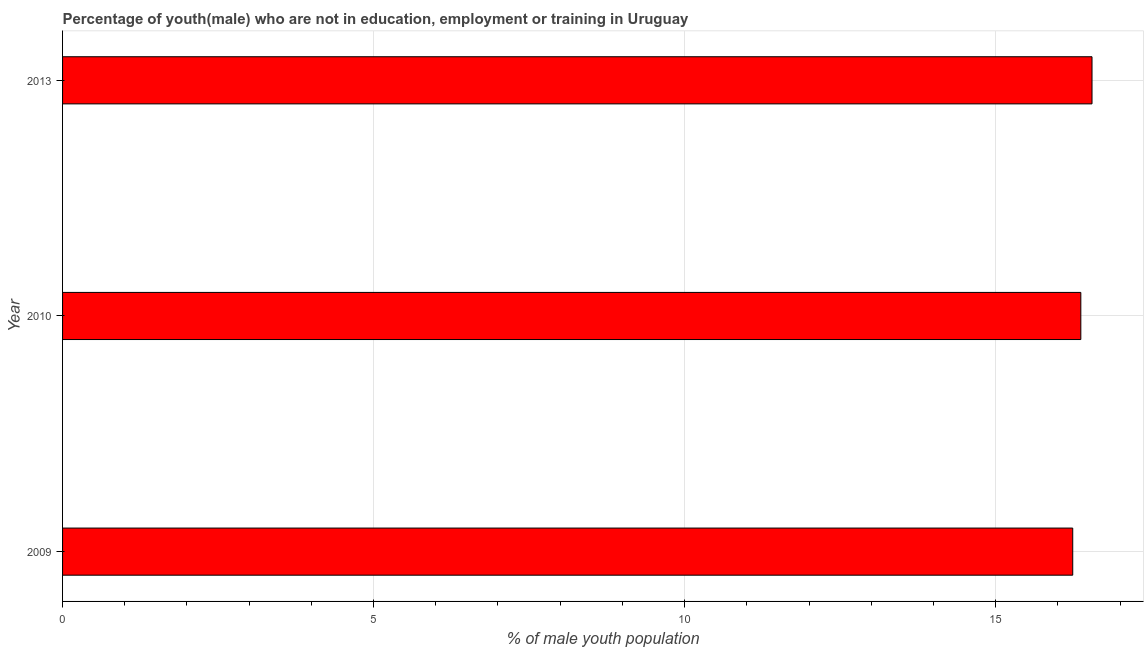Does the graph contain any zero values?
Keep it short and to the point. No. Does the graph contain grids?
Offer a terse response. Yes. What is the title of the graph?
Provide a short and direct response. Percentage of youth(male) who are not in education, employment or training in Uruguay. What is the label or title of the X-axis?
Keep it short and to the point. % of male youth population. What is the unemployed male youth population in 2013?
Keep it short and to the point. 16.55. Across all years, what is the maximum unemployed male youth population?
Your answer should be very brief. 16.55. Across all years, what is the minimum unemployed male youth population?
Offer a terse response. 16.24. In which year was the unemployed male youth population maximum?
Provide a succinct answer. 2013. In which year was the unemployed male youth population minimum?
Provide a succinct answer. 2009. What is the sum of the unemployed male youth population?
Give a very brief answer. 49.16. What is the difference between the unemployed male youth population in 2009 and 2013?
Your answer should be very brief. -0.31. What is the average unemployed male youth population per year?
Ensure brevity in your answer.  16.39. What is the median unemployed male youth population?
Your answer should be compact. 16.37. In how many years, is the unemployed male youth population greater than 10 %?
Offer a very short reply. 3. Do a majority of the years between 2009 and 2013 (inclusive) have unemployed male youth population greater than 16 %?
Keep it short and to the point. Yes. Is the difference between the unemployed male youth population in 2010 and 2013 greater than the difference between any two years?
Offer a very short reply. No. What is the difference between the highest and the second highest unemployed male youth population?
Your answer should be compact. 0.18. What is the difference between the highest and the lowest unemployed male youth population?
Your response must be concise. 0.31. In how many years, is the unemployed male youth population greater than the average unemployed male youth population taken over all years?
Make the answer very short. 1. Are the values on the major ticks of X-axis written in scientific E-notation?
Offer a very short reply. No. What is the % of male youth population in 2009?
Offer a terse response. 16.24. What is the % of male youth population in 2010?
Offer a very short reply. 16.37. What is the % of male youth population of 2013?
Your answer should be compact. 16.55. What is the difference between the % of male youth population in 2009 and 2010?
Ensure brevity in your answer.  -0.13. What is the difference between the % of male youth population in 2009 and 2013?
Make the answer very short. -0.31. What is the difference between the % of male youth population in 2010 and 2013?
Your response must be concise. -0.18. What is the ratio of the % of male youth population in 2009 to that in 2010?
Give a very brief answer. 0.99. What is the ratio of the % of male youth population in 2009 to that in 2013?
Provide a short and direct response. 0.98. What is the ratio of the % of male youth population in 2010 to that in 2013?
Provide a short and direct response. 0.99. 